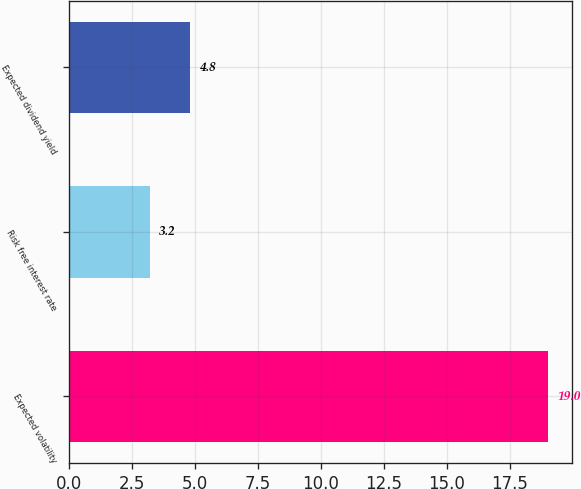Convert chart. <chart><loc_0><loc_0><loc_500><loc_500><bar_chart><fcel>Expected volatility<fcel>Risk free interest rate<fcel>Expected dividend yield<nl><fcel>19<fcel>3.2<fcel>4.8<nl></chart> 